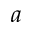<formula> <loc_0><loc_0><loc_500><loc_500>a</formula> 